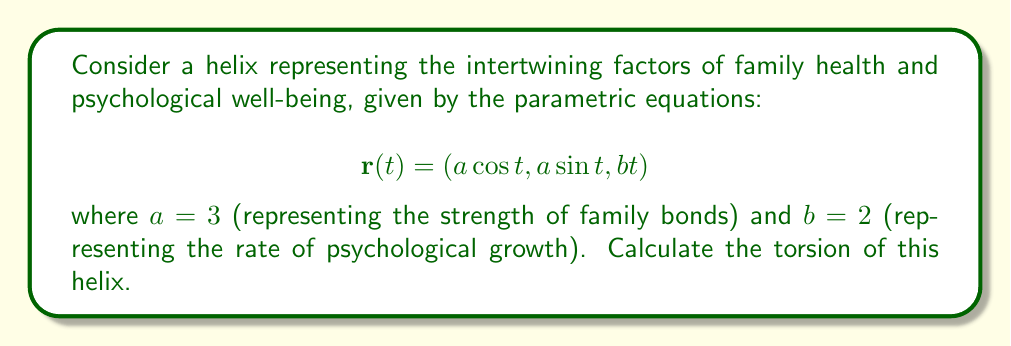Could you help me with this problem? To calculate the torsion of the helix, we'll follow these steps:

1) First, we need to find $\mathbf{r}'(t)$, $\mathbf{r}''(t)$, and $\mathbf{r}'''(t)$:

   $$\mathbf{r}'(t) = (-a \sin t, a \cos t, b)$$
   $$\mathbf{r}''(t) = (-a \cos t, -a \sin t, 0)$$
   $$\mathbf{r}'''(t) = (a \sin t, -a \cos t, 0)$$

2) The torsion $\tau$ is given by the formula:

   $$\tau = \frac{(\mathbf{r}' \times \mathbf{r}'') \cdot \mathbf{r}'''}{|\mathbf{r}' \times \mathbf{r}''|^2}$$

3) Let's calculate $\mathbf{r}' \times \mathbf{r}''$:

   $$\mathbf{r}' \times \mathbf{r}'' = \begin{vmatrix} 
   \mathbf{i} & \mathbf{j} & \mathbf{k} \\
   -a \sin t & a \cos t & b \\
   -a \cos t & -a \sin t & 0
   \end{vmatrix}$$

   $$= (ab \sin t)\mathbf{i} + (ab \cos t)\mathbf{j} + (a^2)\mathbf{k}$$

4) Now, let's calculate $(\mathbf{r}' \times \mathbf{r}'') \cdot \mathbf{r}'''$:

   $$(ab \sin t, ab \cos t, a^2) \cdot (a \sin t, -a \cos t, 0) = a^2b \sin^2 t - a^2b \cos^2 t = -a^2b \cos 2t$$

5) Next, we need $|\mathbf{r}' \times \mathbf{r}''|^2$:

   $$|(ab \sin t, ab \cos t, a^2)|^2 = a^2b^2 \sin^2 t + a^2b^2 \cos^2 t + a^4 = a^2(b^2 + a^2)$$

6) Substituting these into the torsion formula:

   $$\tau = \frac{-a^2b \cos 2t}{a^2(b^2 + a^2)} = -\frac{b \cos 2t}{b^2 + a^2}$$

7) However, for a helix, the torsion is constant. The $\cos 2t$ term will cancel out. We can see this by using the identity $\cos 2t = 1 - 2\sin^2 t$:

   $$\tau = -\frac{b(1 - 2\sin^2 t)}{b^2 + a^2} = -\frac{b}{b^2 + a^2}$$

8) Finally, substituting the given values $a = 3$ and $b = 2$:

   $$\tau = -\frac{2}{2^2 + 3^2} = -\frac{2}{13}$$

The negative sign indicates that the helix is left-handed.
Answer: $$-\frac{2}{13}$$ 